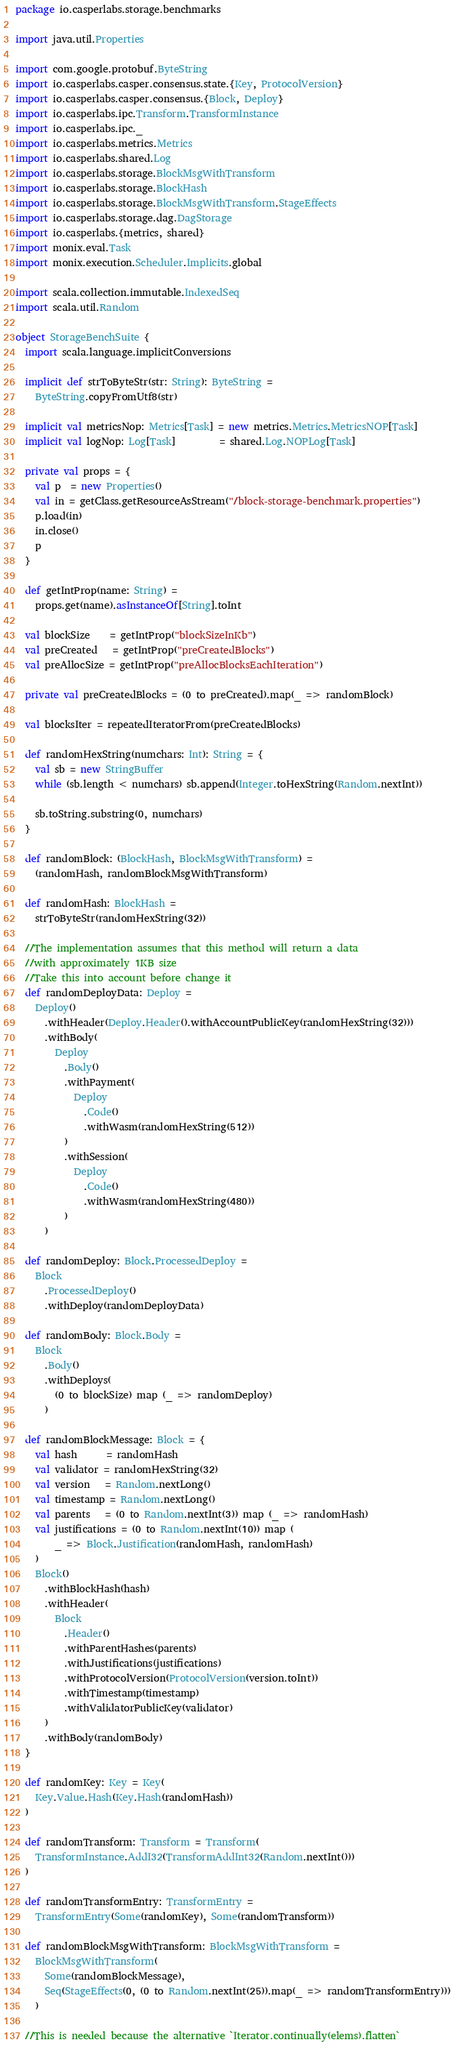Convert code to text. <code><loc_0><loc_0><loc_500><loc_500><_Scala_>package io.casperlabs.storage.benchmarks

import java.util.Properties

import com.google.protobuf.ByteString
import io.casperlabs.casper.consensus.state.{Key, ProtocolVersion}
import io.casperlabs.casper.consensus.{Block, Deploy}
import io.casperlabs.ipc.Transform.TransformInstance
import io.casperlabs.ipc._
import io.casperlabs.metrics.Metrics
import io.casperlabs.shared.Log
import io.casperlabs.storage.BlockMsgWithTransform
import io.casperlabs.storage.BlockHash
import io.casperlabs.storage.BlockMsgWithTransform.StageEffects
import io.casperlabs.storage.dag.DagStorage
import io.casperlabs.{metrics, shared}
import monix.eval.Task
import monix.execution.Scheduler.Implicits.global

import scala.collection.immutable.IndexedSeq
import scala.util.Random

object StorageBenchSuite {
  import scala.language.implicitConversions

  implicit def strToByteStr(str: String): ByteString =
    ByteString.copyFromUtf8(str)

  implicit val metricsNop: Metrics[Task] = new metrics.Metrics.MetricsNOP[Task]
  implicit val logNop: Log[Task]         = shared.Log.NOPLog[Task]

  private val props = {
    val p  = new Properties()
    val in = getClass.getResourceAsStream("/block-storage-benchmark.properties")
    p.load(in)
    in.close()
    p
  }

  def getIntProp(name: String) =
    props.get(name).asInstanceOf[String].toInt

  val blockSize    = getIntProp("blockSizeInKb")
  val preCreated   = getIntProp("preCreatedBlocks")
  val preAllocSize = getIntProp("preAllocBlocksEachIteration")

  private val preCreatedBlocks = (0 to preCreated).map(_ => randomBlock)

  val blocksIter = repeatedIteratorFrom(preCreatedBlocks)

  def randomHexString(numchars: Int): String = {
    val sb = new StringBuffer
    while (sb.length < numchars) sb.append(Integer.toHexString(Random.nextInt))

    sb.toString.substring(0, numchars)
  }

  def randomBlock: (BlockHash, BlockMsgWithTransform) =
    (randomHash, randomBlockMsgWithTransform)

  def randomHash: BlockHash =
    strToByteStr(randomHexString(32))

  //The implementation assumes that this method will return a data
  //with approximately 1KB size
  //Take this into account before change it
  def randomDeployData: Deploy =
    Deploy()
      .withHeader(Deploy.Header().withAccountPublicKey(randomHexString(32)))
      .withBody(
        Deploy
          .Body()
          .withPayment(
            Deploy
              .Code()
              .withWasm(randomHexString(512))
          )
          .withSession(
            Deploy
              .Code()
              .withWasm(randomHexString(480))
          )
      )

  def randomDeploy: Block.ProcessedDeploy =
    Block
      .ProcessedDeploy()
      .withDeploy(randomDeployData)

  def randomBody: Block.Body =
    Block
      .Body()
      .withDeploys(
        (0 to blockSize) map (_ => randomDeploy)
      )

  def randomBlockMessage: Block = {
    val hash      = randomHash
    val validator = randomHexString(32)
    val version   = Random.nextLong()
    val timestamp = Random.nextLong()
    val parents   = (0 to Random.nextInt(3)) map (_ => randomHash)
    val justifications = (0 to Random.nextInt(10)) map (
        _ => Block.Justification(randomHash, randomHash)
    )
    Block()
      .withBlockHash(hash)
      .withHeader(
        Block
          .Header()
          .withParentHashes(parents)
          .withJustifications(justifications)
          .withProtocolVersion(ProtocolVersion(version.toInt))
          .withTimestamp(timestamp)
          .withValidatorPublicKey(validator)
      )
      .withBody(randomBody)
  }

  def randomKey: Key = Key(
    Key.Value.Hash(Key.Hash(randomHash))
  )

  def randomTransform: Transform = Transform(
    TransformInstance.AddI32(TransformAddInt32(Random.nextInt()))
  )

  def randomTransformEntry: TransformEntry =
    TransformEntry(Some(randomKey), Some(randomTransform))

  def randomBlockMsgWithTransform: BlockMsgWithTransform =
    BlockMsgWithTransform(
      Some(randomBlockMessage),
      Seq(StageEffects(0, (0 to Random.nextInt(25)).map(_ => randomTransformEntry)))
    )

  //This is needed because the alternative `Iterator.continually(elems).flatten`</code> 